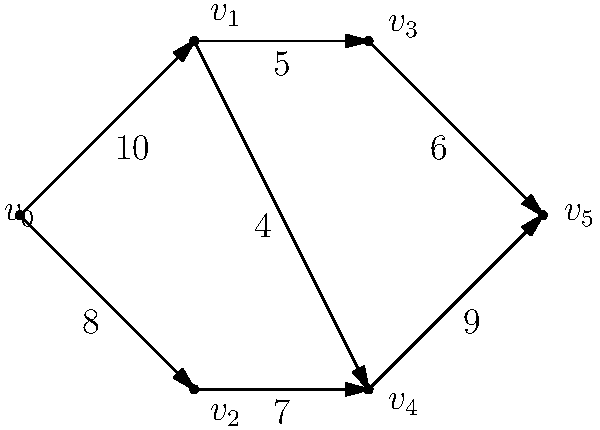Consider the network flow diagram representing the spread of information about a recent scientific breakthrough on social media platforms. The vertices represent different social media channels, and the edges represent the capacity of information flow between them. What is the maximum flow of information from the source ($v_0$) to the sink ($v_5$)? To find the maximum flow in this network, we'll use the Ford-Fulkerson algorithm:

1. Initialize flow to 0.

2. Find augmenting paths from source to sink:
   
   a) Path: $v_0 \rightarrow v_1 \rightarrow v_3 \rightarrow v_5$
      Min capacity: $\min(10, 5, 6) = 5$
      Flow becomes 5

   b) Path: $v_0 \rightarrow v_1 \rightarrow v_4 \rightarrow v_5$
      Min capacity: $\min(10-5, 4, 9) = 4$
      Flow becomes 9

   c) Path: $v_0 \rightarrow v_2 \rightarrow v_4 \rightarrow v_5$
      Min capacity: $\min(8, 7, 9-4) = 5$
      Flow becomes 14

3. No more augmenting paths exist.

Therefore, the maximum flow from $v_0$ to $v_5$ is 14 units of information.
Answer: 14 units 